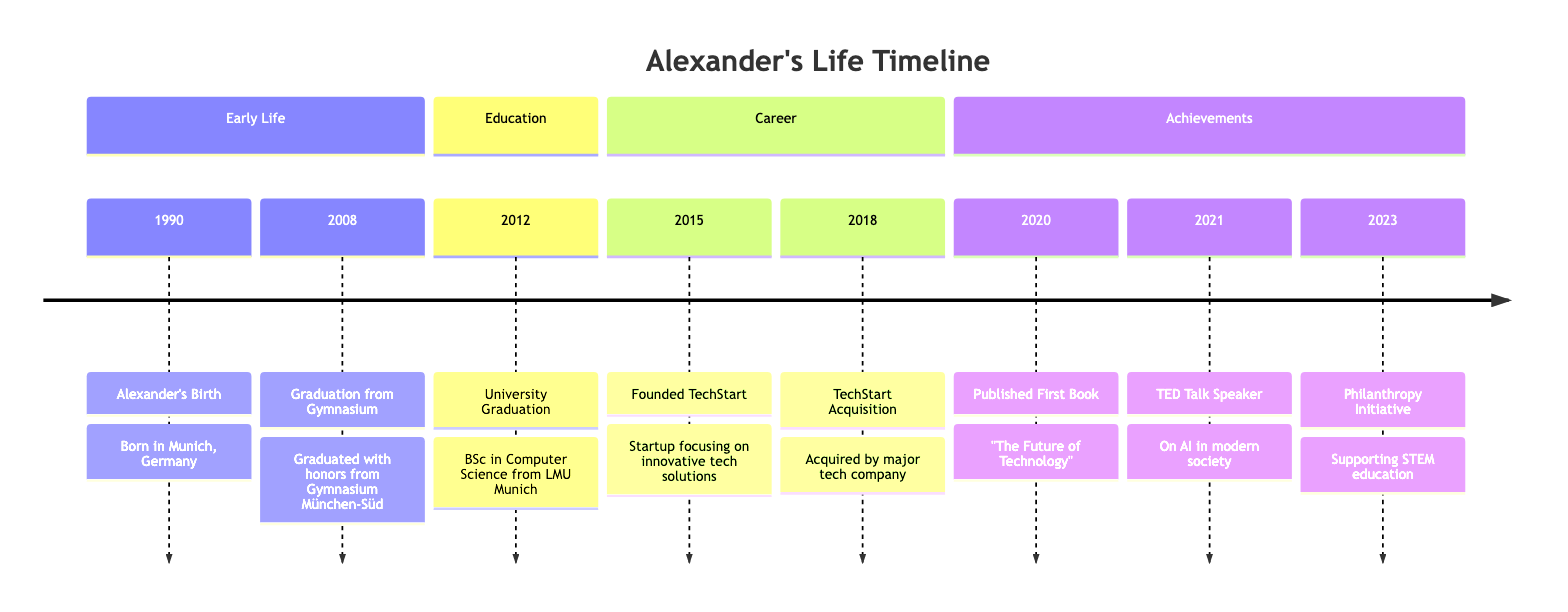What event occurred in 1990? The diagram indicates that the event in 1990 is "Alexander's Birth," which took place in Munich, Germany.
Answer: Alexander's Birth How many major life events are listed in the timeline? By counting the events in the timeline, there are seven major life events documented, from birth through the philanthropy initiative in 2023.
Answer: 7 What significant event happened in 2015? The timeline shows that in 2015, Alexander founded TechStart, a startup focused on innovative tech solutions.
Answer: Founded TechStart Which event directly followed the acquisition of TechStart? The timeline displays that after the TechStart acquisition in 2018, the next event listed is the publication of Alexander's first book in 2020.
Answer: Published First Book What was the focus of Alexander's first book published in 2020? The diagram states that Alexander's first book is titled "The Future of Technology," which implies a focus on technology.
Answer: The Future of Technology How many years passed between Alexander's birth and his graduation from university? By subtracting the year of Alexander's birth (1990) from his university graduation (2012), we find that 22 years passed between these two events.
Answer: 22 years What type of initiative did Alexander launch in 2023? The timeline indicates that in 2023, Alexander launched a philanthropic initiative, specifically aimed at supporting STEM education for underprivileged students.
Answer: Philanthropy Initiative Which major tech event occurred in 2018? According to the timeline, the significant tech event in 2018 was the acquisition of TechStart by a major technology company.
Answer: TechStart Acquisition What was the subject of Alexander's TED Talk in 2021? The timeline specifies that the subject of Alexander's TED Talk in 2021 was on the importance of AI in modern society.
Answer: AI in modern society 